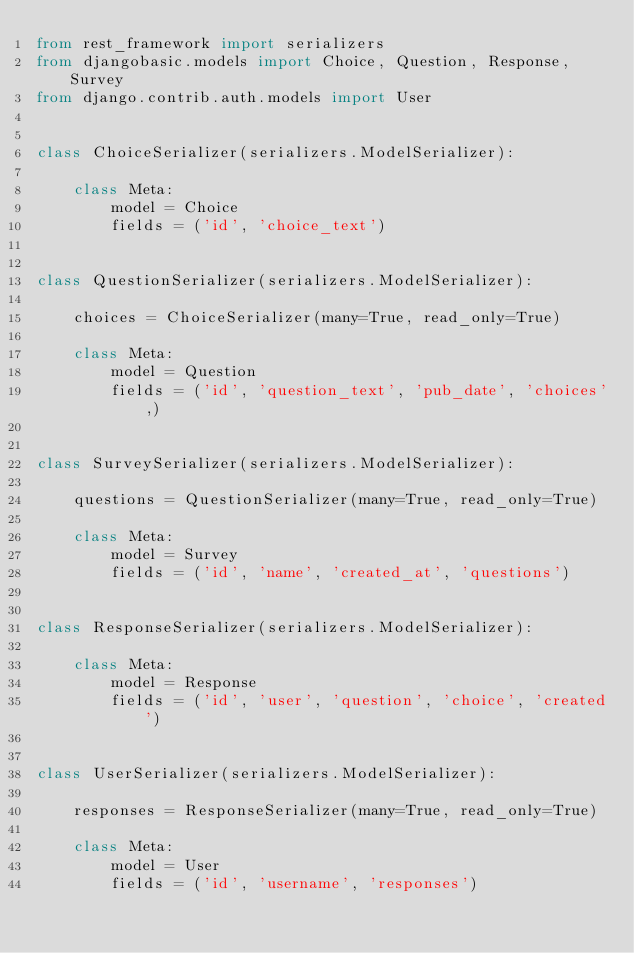Convert code to text. <code><loc_0><loc_0><loc_500><loc_500><_Python_>from rest_framework import serializers
from djangobasic.models import Choice, Question, Response, Survey
from django.contrib.auth.models import User


class ChoiceSerializer(serializers.ModelSerializer):

    class Meta:
        model = Choice
        fields = ('id', 'choice_text')


class QuestionSerializer(serializers.ModelSerializer):

    choices = ChoiceSerializer(many=True, read_only=True)

    class Meta:
        model = Question
        fields = ('id', 'question_text', 'pub_date', 'choices',)


class SurveySerializer(serializers.ModelSerializer):

    questions = QuestionSerializer(many=True, read_only=True)

    class Meta:
        model = Survey
        fields = ('id', 'name', 'created_at', 'questions')


class ResponseSerializer(serializers.ModelSerializer):

    class Meta:
        model = Response
        fields = ('id', 'user', 'question', 'choice', 'created')


class UserSerializer(serializers.ModelSerializer):

    responses = ResponseSerializer(many=True, read_only=True)

    class Meta:
        model = User
        fields = ('id', 'username', 'responses')
</code> 